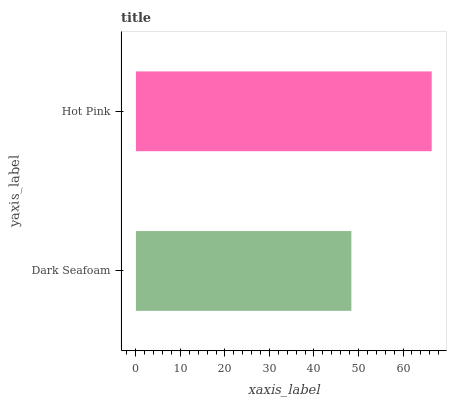Is Dark Seafoam the minimum?
Answer yes or no. Yes. Is Hot Pink the maximum?
Answer yes or no. Yes. Is Hot Pink the minimum?
Answer yes or no. No. Is Hot Pink greater than Dark Seafoam?
Answer yes or no. Yes. Is Dark Seafoam less than Hot Pink?
Answer yes or no. Yes. Is Dark Seafoam greater than Hot Pink?
Answer yes or no. No. Is Hot Pink less than Dark Seafoam?
Answer yes or no. No. Is Hot Pink the high median?
Answer yes or no. Yes. Is Dark Seafoam the low median?
Answer yes or no. Yes. Is Dark Seafoam the high median?
Answer yes or no. No. Is Hot Pink the low median?
Answer yes or no. No. 